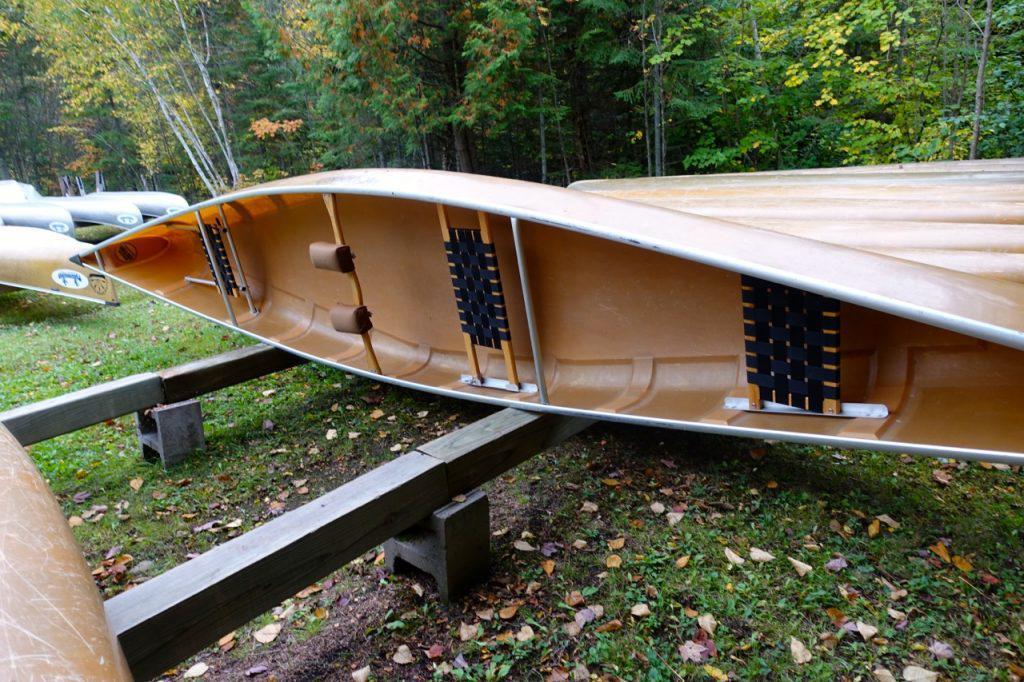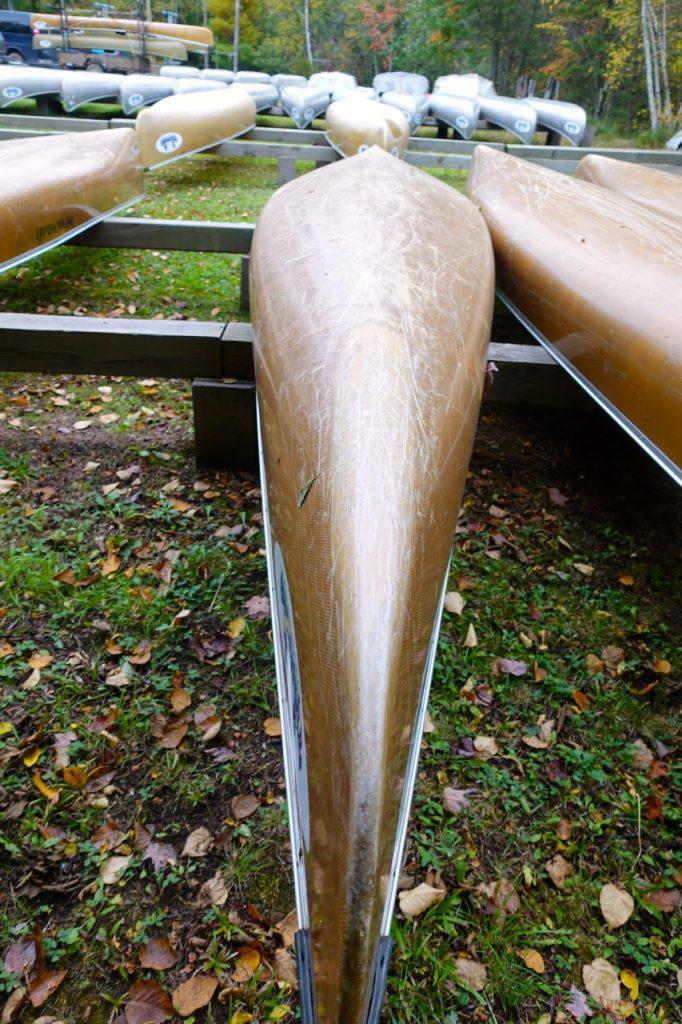The first image is the image on the left, the second image is the image on the right. Considering the images on both sides, is "Two canoes are sitting on the ground." valid? Answer yes or no. No. The first image is the image on the left, the second image is the image on the right. Assess this claim about the two images: "The left and right image contains the same number of boat on land.". Correct or not? Answer yes or no. No. 